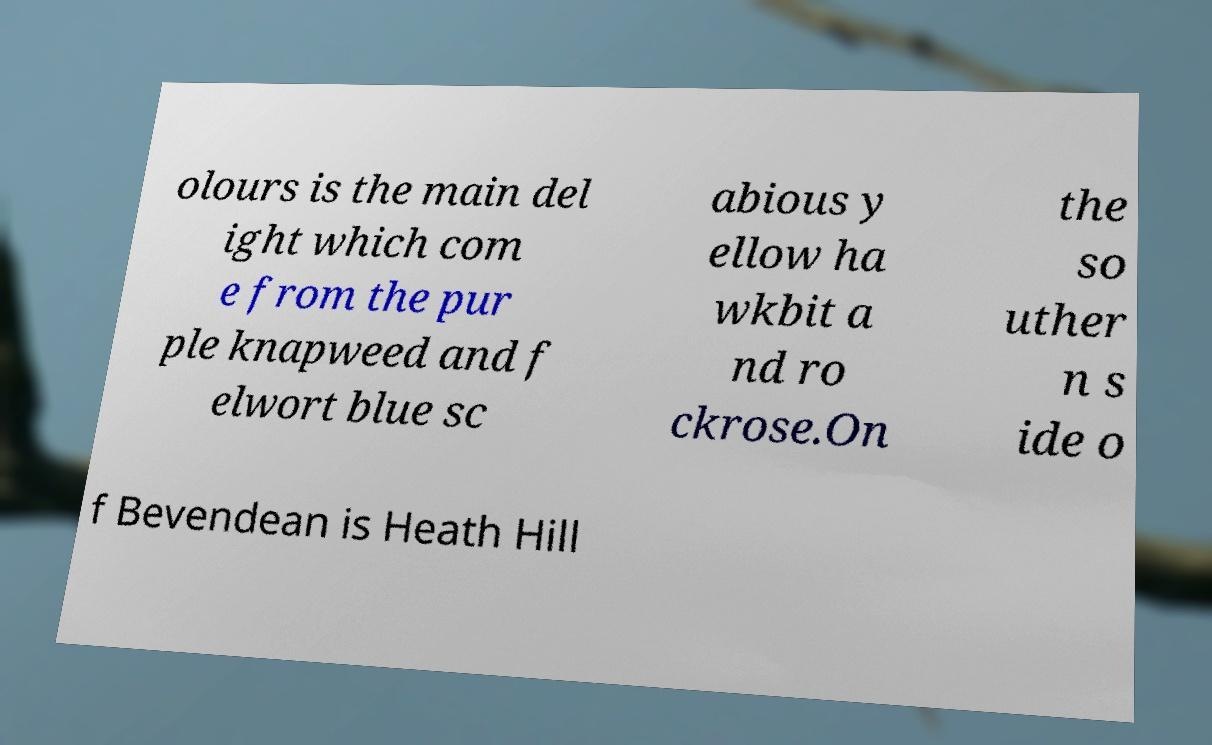Can you read and provide the text displayed in the image?This photo seems to have some interesting text. Can you extract and type it out for me? olours is the main del ight which com e from the pur ple knapweed and f elwort blue sc abious y ellow ha wkbit a nd ro ckrose.On the so uther n s ide o f Bevendean is Heath Hill 